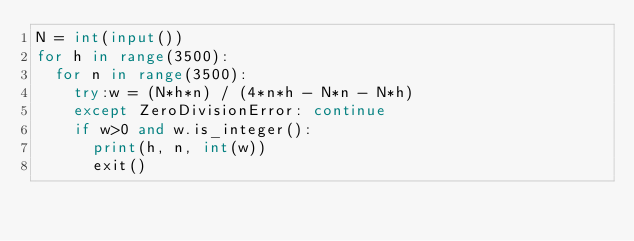Convert code to text. <code><loc_0><loc_0><loc_500><loc_500><_Python_>N = int(input())
for h in range(3500):
  for n in range(3500):
    try:w = (N*h*n) / (4*n*h - N*n - N*h)
    except ZeroDivisionError: continue
    if w>0 and w.is_integer():
      print(h, n, int(w))
      exit()</code> 